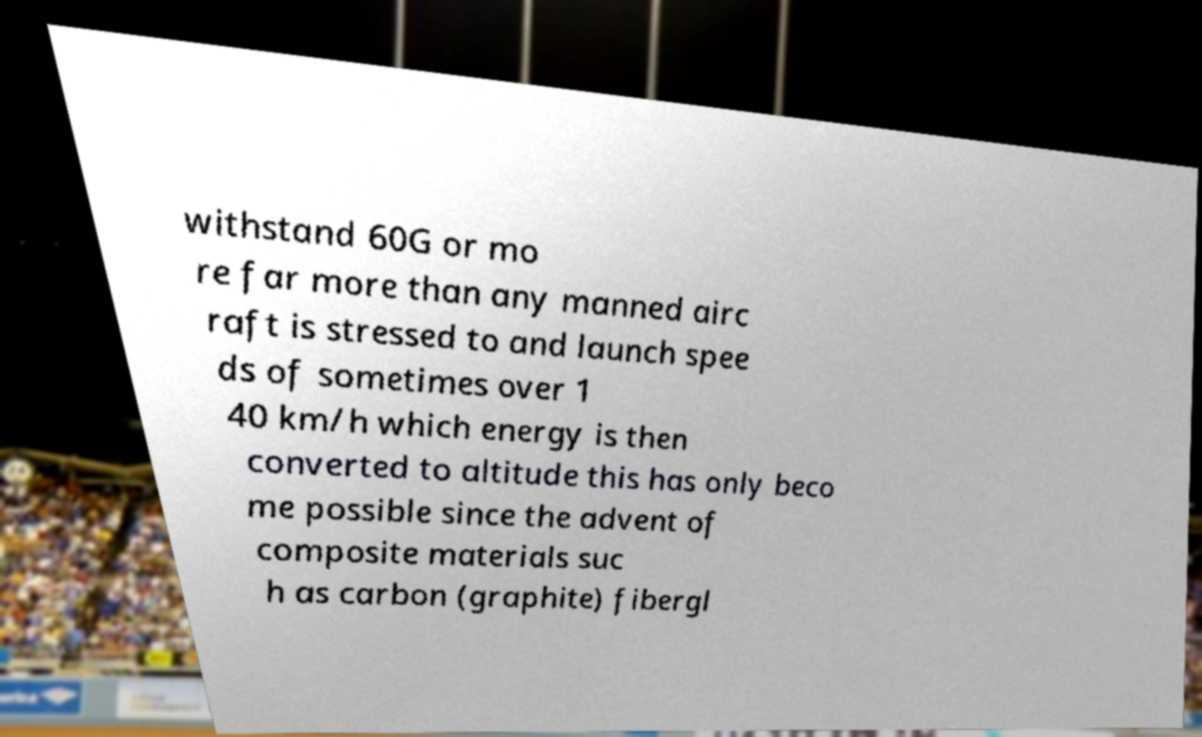For documentation purposes, I need the text within this image transcribed. Could you provide that? withstand 60G or mo re far more than any manned airc raft is stressed to and launch spee ds of sometimes over 1 40 km/h which energy is then converted to altitude this has only beco me possible since the advent of composite materials suc h as carbon (graphite) fibergl 